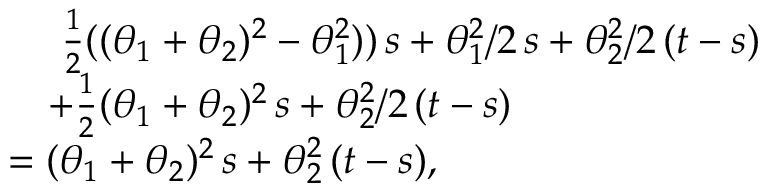<formula> <loc_0><loc_0><loc_500><loc_500>\begin{array} { r l } & { \frac { 1 } { 2 } ( ( \theta _ { 1 } + \theta _ { 2 } ) ^ { 2 } - \theta _ { 1 } ^ { 2 } ) ) \, s + \theta _ { 1 } ^ { 2 } / 2 \, s + \theta _ { 2 } ^ { 2 } / 2 \, ( t - s ) } \\ & { + \frac { 1 } { 2 } ( \theta _ { 1 } + \theta _ { 2 } ) ^ { 2 } \, s + \theta _ { 2 } ^ { 2 } / 2 \, ( t - s ) } \\ & { = ( \theta _ { 1 } + \theta _ { 2 } ) ^ { 2 } \, s + \theta _ { 2 } ^ { 2 } \, ( t - s ) , } \end{array}</formula> 